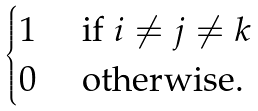<formula> <loc_0><loc_0><loc_500><loc_500>\begin{cases} 1 & \text { if } i \ne j \ne k \\ 0 & \text { otherwise.} \end{cases}</formula> 